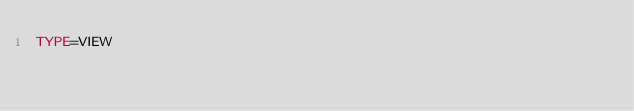<code> <loc_0><loc_0><loc_500><loc_500><_VisualBasic_>TYPE=VIEW</code> 